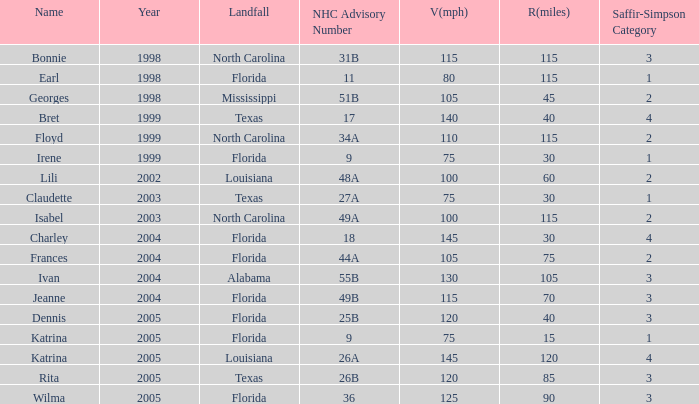Could you help me parse every detail presented in this table? {'header': ['Name', 'Year', 'Landfall', 'NHC Advisory Number', 'V(mph)', 'R(miles)', 'Saffir-Simpson Category'], 'rows': [['Bonnie', '1998', 'North Carolina', '31B', '115', '115', '3'], ['Earl', '1998', 'Florida', '11', '80', '115', '1'], ['Georges', '1998', 'Mississippi', '51B', '105', '45', '2'], ['Bret', '1999', 'Texas', '17', '140', '40', '4'], ['Floyd', '1999', 'North Carolina', '34A', '110', '115', '2'], ['Irene', '1999', 'Florida', '9', '75', '30', '1'], ['Lili', '2002', 'Louisiana', '48A', '100', '60', '2'], ['Claudette', '2003', 'Texas', '27A', '75', '30', '1'], ['Isabel', '2003', 'North Carolina', '49A', '100', '115', '2'], ['Charley', '2004', 'Florida', '18', '145', '30', '4'], ['Frances', '2004', 'Florida', '44A', '105', '75', '2'], ['Ivan', '2004', 'Alabama', '55B', '130', '105', '3'], ['Jeanne', '2004', 'Florida', '49B', '115', '70', '3'], ['Dennis', '2005', 'Florida', '25B', '120', '40', '3'], ['Katrina', '2005', 'Florida', '9', '75', '15', '1'], ['Katrina', '2005', 'Louisiana', '26A', '145', '120', '4'], ['Rita', '2005', 'Texas', '26B', '120', '85', '3'], ['Wilma', '2005', 'Florida', '36', '125', '90', '3']]} What was the peak saffir-simpson level with an nhc advisory of 18? 4.0. 